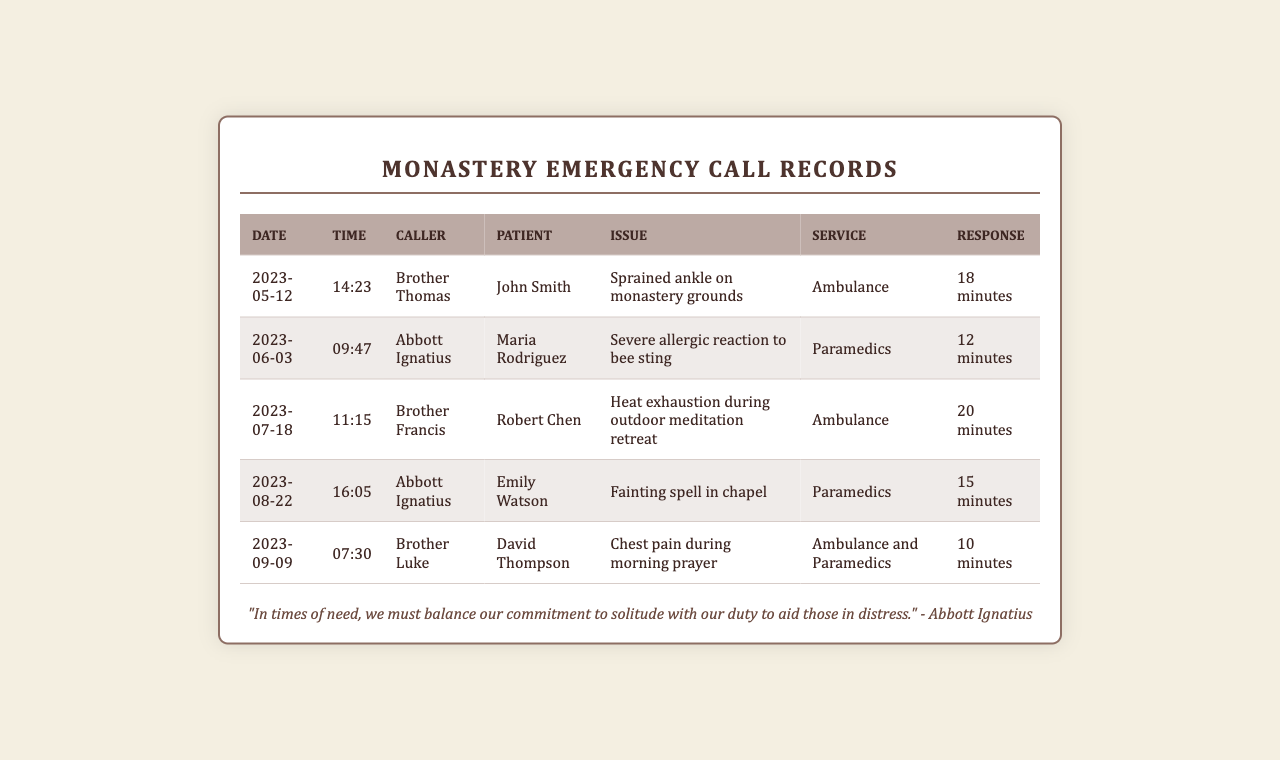What is the date of the first emergency call? The first emergency call recorded is on May 12, 2023.
Answer: May 12, 2023 Who called about the chest pain during morning prayer? The caller regarding the chest pain during morning prayer is Brother Luke.
Answer: Brother Luke What was the response time for the severe allergic reaction? The response time for the severe allergic reaction was 12 minutes.
Answer: 12 minutes How many emergency calls were made in total? There are a total of five emergency calls listed in the document.
Answer: 5 What issue did Maria Rodriguez experience? Maria Rodriguez experienced a severe allergic reaction to a bee sting.
Answer: Severe allergic reaction to bee sting Which patient had a sprained ankle? The patient with a sprained ankle was John Smith.
Answer: John Smith Which emergency service was called for David Thompson? Both an ambulance and paramedics were called for David Thompson.
Answer: Ambulance and Paramedics What type of issue occurred during the outdoor meditation retreat? The issue that occurred was heat exhaustion.
Answer: Heat exhaustion 